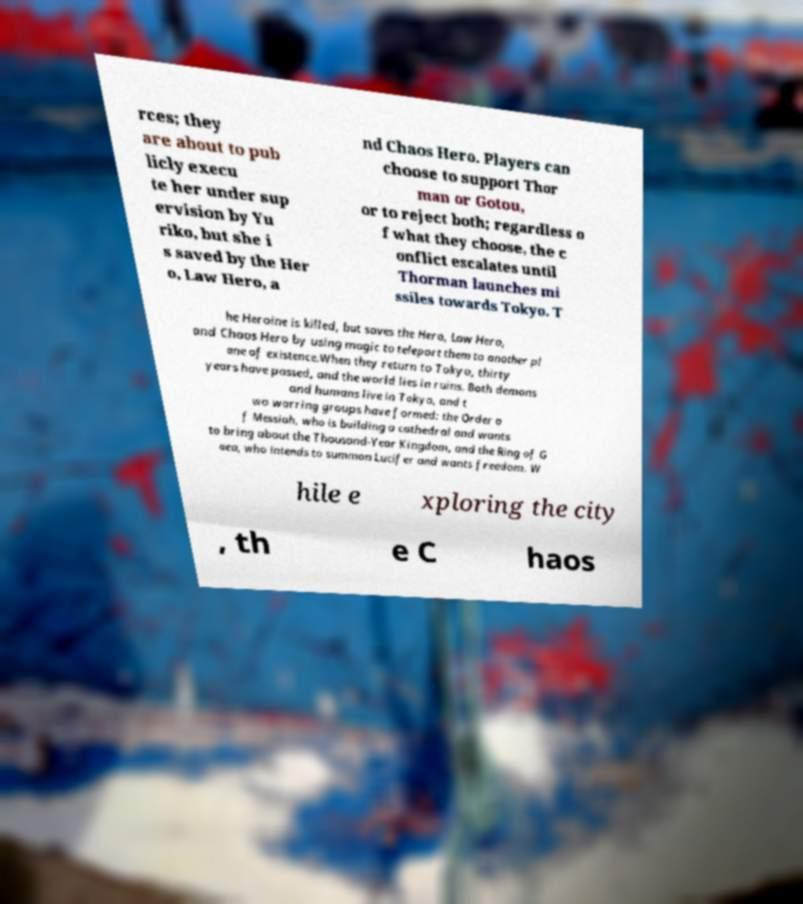I need the written content from this picture converted into text. Can you do that? rces; they are about to pub licly execu te her under sup ervision by Yu riko, but she i s saved by the Her o, Law Hero, a nd Chaos Hero. Players can choose to support Thor man or Gotou, or to reject both; regardless o f what they choose, the c onflict escalates until Thorman launches mi ssiles towards Tokyo. T he Heroine is killed, but saves the Hero, Law Hero, and Chaos Hero by using magic to teleport them to another pl ane of existence.When they return to Tokyo, thirty years have passed, and the world lies in ruins. Both demons and humans live in Tokyo, and t wo warring groups have formed: the Order o f Messiah, who is building a cathedral and wants to bring about the Thousand-Year Kingdom, and the Ring of G aea, who intends to summon Lucifer and wants freedom. W hile e xploring the city , th e C haos 